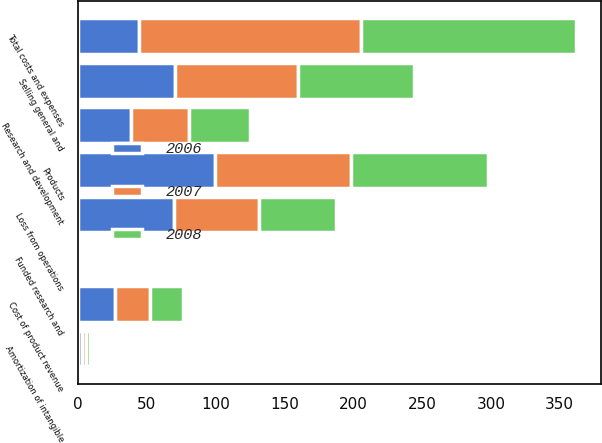Convert chart. <chart><loc_0><loc_0><loc_500><loc_500><stacked_bar_chart><ecel><fcel>Products<fcel>Funded research and<fcel>Cost of product revenue<fcel>Research and development<fcel>Selling general and<fcel>Amortization of intangible<fcel>Total costs and expenses<fcel>Loss from operations<nl><fcel>2007<fcel>98.9<fcel>1.1<fcel>25.6<fcel>42.3<fcel>89.3<fcel>2.7<fcel>161.9<fcel>61.9<nl><fcel>2008<fcel>99.5<fcel>0.5<fcel>23.7<fcel>44<fcel>83.8<fcel>3.2<fcel>156.3<fcel>56.3<nl><fcel>2006<fcel>99.2<fcel>0.8<fcel>26.8<fcel>38.3<fcel>70.7<fcel>3<fcel>44<fcel>69.3<nl></chart> 